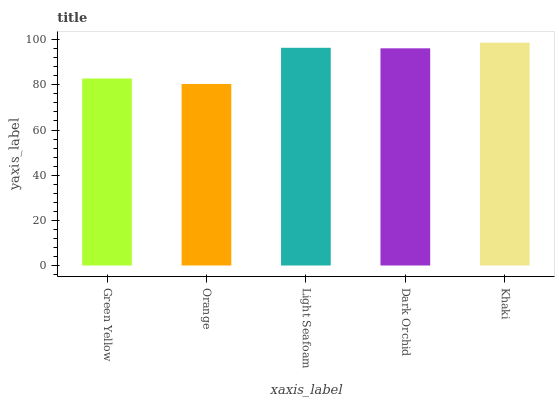Is Orange the minimum?
Answer yes or no. Yes. Is Khaki the maximum?
Answer yes or no. Yes. Is Light Seafoam the minimum?
Answer yes or no. No. Is Light Seafoam the maximum?
Answer yes or no. No. Is Light Seafoam greater than Orange?
Answer yes or no. Yes. Is Orange less than Light Seafoam?
Answer yes or no. Yes. Is Orange greater than Light Seafoam?
Answer yes or no. No. Is Light Seafoam less than Orange?
Answer yes or no. No. Is Dark Orchid the high median?
Answer yes or no. Yes. Is Dark Orchid the low median?
Answer yes or no. Yes. Is Khaki the high median?
Answer yes or no. No. Is Khaki the low median?
Answer yes or no. No. 